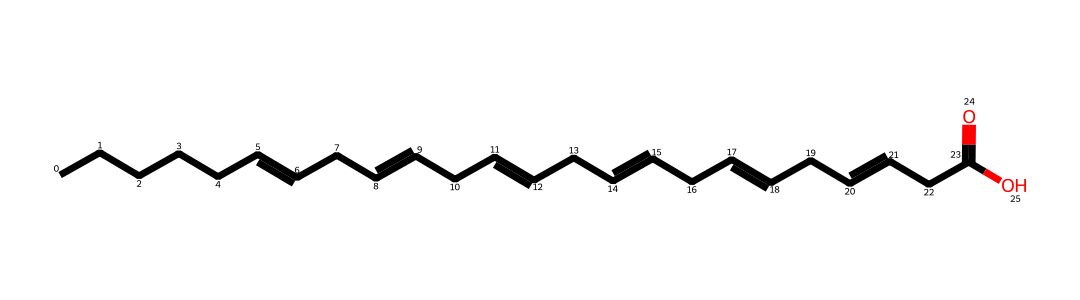What type of molecule is represented by this SMILES? The structure is indicative of a fatty acid, characterized by long hydrocarbon chains and a carboxyl group at one end. This is common for lipid molecules.
Answer: fatty acid How many carbon atoms does this fatty acid contain? By counting the 'C' characters in the SMILES representation, including those involved in double bonds, we find there are 18 carbon atoms.
Answer: 18 What is the main functional group in this molecule? The presence of the 'C(=O)O' portion indicates the presence of a carboxylic acid functional group, which is crucial for fatty acids.
Answer: carboxylic acid How many double bonds are present in this fatty acid? Observing the structure, we notice there are 4 double bonds indicated by the '=' in the SMILES.
Answer: 4 What type of double bonds are found in this fatty acid? The presence of multiple double bonds in the structure classifies this fatty acid as polyunsaturated, as it has more than one double bond in its carbon chain.
Answer: polyunsaturated Does this fatty acid belong to the omega-3 family? Since the first double bond is located at the third carbon from the end of the chain, it qualifies this fatty acid as an omega-3 fatty acid.
Answer: yes What is a primary source of this omega-3 fatty acid? Fish oils are a well-known source of omega-3 fatty acids, as they contain various forms of these beneficial fats, making them widely consumed as supplements.
Answer: fish oil 